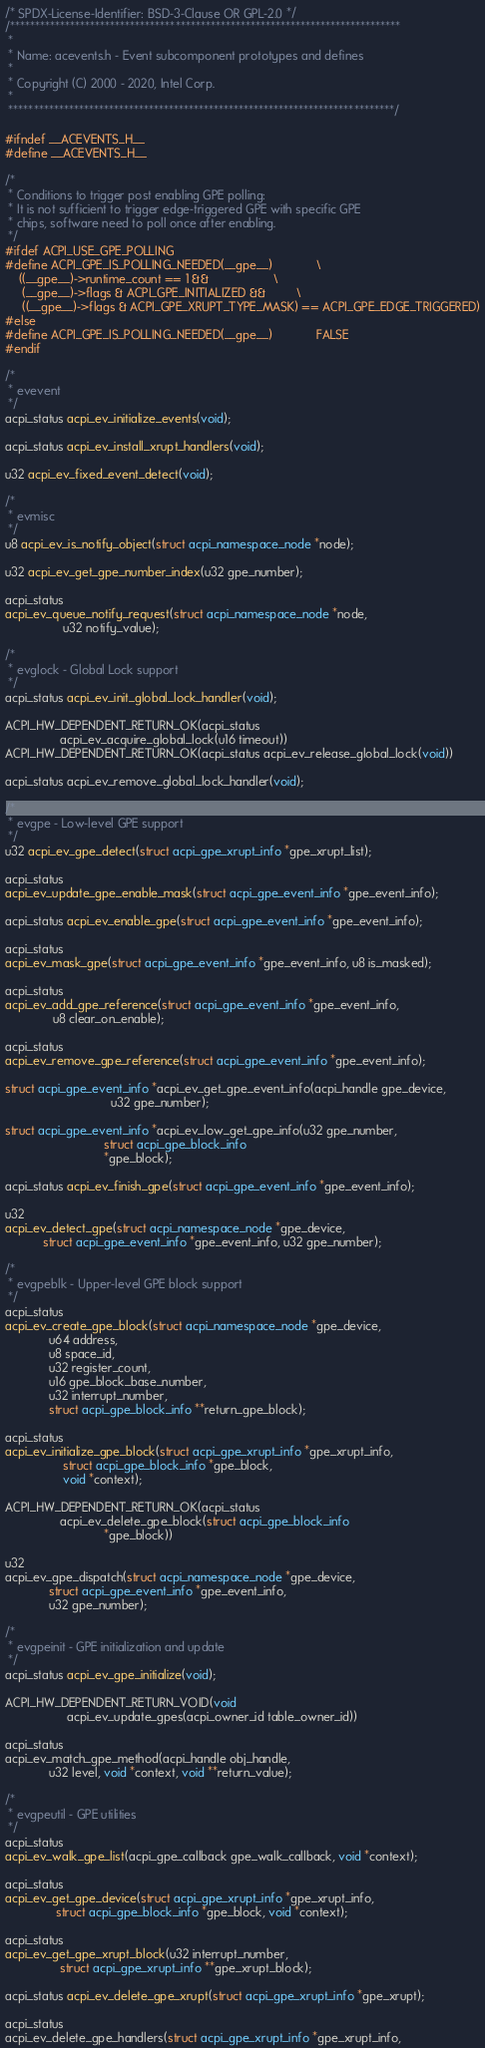<code> <loc_0><loc_0><loc_500><loc_500><_C_>/* SPDX-License-Identifier: BSD-3-Clause OR GPL-2.0 */
/******************************************************************************
 *
 * Name: acevents.h - Event subcomponent prototypes and defines
 *
 * Copyright (C) 2000 - 2020, Intel Corp.
 *
 *****************************************************************************/

#ifndef __ACEVENTS_H__
#define __ACEVENTS_H__

/*
 * Conditions to trigger post enabling GPE polling:
 * It is not sufficient to trigger edge-triggered GPE with specific GPE
 * chips, software need to poll once after enabling.
 */
#ifdef ACPI_USE_GPE_POLLING
#define ACPI_GPE_IS_POLLING_NEEDED(__gpe__)             \
	((__gpe__)->runtime_count == 1 &&                   \
	 (__gpe__)->flags & ACPI_GPE_INITIALIZED &&         \
	 ((__gpe__)->flags & ACPI_GPE_XRUPT_TYPE_MASK) == ACPI_GPE_EDGE_TRIGGERED)
#else
#define ACPI_GPE_IS_POLLING_NEEDED(__gpe__)             FALSE
#endif

/*
 * evevent
 */
acpi_status acpi_ev_initialize_events(void);

acpi_status acpi_ev_install_xrupt_handlers(void);

u32 acpi_ev_fixed_event_detect(void);

/*
 * evmisc
 */
u8 acpi_ev_is_notify_object(struct acpi_namespace_node *node);

u32 acpi_ev_get_gpe_number_index(u32 gpe_number);

acpi_status
acpi_ev_queue_notify_request(struct acpi_namespace_node *node,
			     u32 notify_value);

/*
 * evglock - Global Lock support
 */
acpi_status acpi_ev_init_global_lock_handler(void);

ACPI_HW_DEPENDENT_RETURN_OK(acpi_status
			    acpi_ev_acquire_global_lock(u16 timeout))
ACPI_HW_DEPENDENT_RETURN_OK(acpi_status acpi_ev_release_global_lock(void))

acpi_status acpi_ev_remove_global_lock_handler(void);

/*
 * evgpe - Low-level GPE support
 */
u32 acpi_ev_gpe_detect(struct acpi_gpe_xrupt_info *gpe_xrupt_list);

acpi_status
acpi_ev_update_gpe_enable_mask(struct acpi_gpe_event_info *gpe_event_info);

acpi_status acpi_ev_enable_gpe(struct acpi_gpe_event_info *gpe_event_info);

acpi_status
acpi_ev_mask_gpe(struct acpi_gpe_event_info *gpe_event_info, u8 is_masked);

acpi_status
acpi_ev_add_gpe_reference(struct acpi_gpe_event_info *gpe_event_info,
			  u8 clear_on_enable);

acpi_status
acpi_ev_remove_gpe_reference(struct acpi_gpe_event_info *gpe_event_info);

struct acpi_gpe_event_info *acpi_ev_get_gpe_event_info(acpi_handle gpe_device,
						       u32 gpe_number);

struct acpi_gpe_event_info *acpi_ev_low_get_gpe_info(u32 gpe_number,
						     struct acpi_gpe_block_info
						     *gpe_block);

acpi_status acpi_ev_finish_gpe(struct acpi_gpe_event_info *gpe_event_info);

u32
acpi_ev_detect_gpe(struct acpi_namespace_node *gpe_device,
		   struct acpi_gpe_event_info *gpe_event_info, u32 gpe_number);

/*
 * evgpeblk - Upper-level GPE block support
 */
acpi_status
acpi_ev_create_gpe_block(struct acpi_namespace_node *gpe_device,
			 u64 address,
			 u8 space_id,
			 u32 register_count,
			 u16 gpe_block_base_number,
			 u32 interrupt_number,
			 struct acpi_gpe_block_info **return_gpe_block);

acpi_status
acpi_ev_initialize_gpe_block(struct acpi_gpe_xrupt_info *gpe_xrupt_info,
			     struct acpi_gpe_block_info *gpe_block,
			     void *context);

ACPI_HW_DEPENDENT_RETURN_OK(acpi_status
			    acpi_ev_delete_gpe_block(struct acpi_gpe_block_info
						     *gpe_block))

u32
acpi_ev_gpe_dispatch(struct acpi_namespace_node *gpe_device,
		     struct acpi_gpe_event_info *gpe_event_info,
		     u32 gpe_number);

/*
 * evgpeinit - GPE initialization and update
 */
acpi_status acpi_ev_gpe_initialize(void);

ACPI_HW_DEPENDENT_RETURN_VOID(void
			      acpi_ev_update_gpes(acpi_owner_id table_owner_id))

acpi_status
acpi_ev_match_gpe_method(acpi_handle obj_handle,
			 u32 level, void *context, void **return_value);

/*
 * evgpeutil - GPE utilities
 */
acpi_status
acpi_ev_walk_gpe_list(acpi_gpe_callback gpe_walk_callback, void *context);

acpi_status
acpi_ev_get_gpe_device(struct acpi_gpe_xrupt_info *gpe_xrupt_info,
		       struct acpi_gpe_block_info *gpe_block, void *context);

acpi_status
acpi_ev_get_gpe_xrupt_block(u32 interrupt_number,
			    struct acpi_gpe_xrupt_info **gpe_xrupt_block);

acpi_status acpi_ev_delete_gpe_xrupt(struct acpi_gpe_xrupt_info *gpe_xrupt);

acpi_status
acpi_ev_delete_gpe_handlers(struct acpi_gpe_xrupt_info *gpe_xrupt_info,</code> 